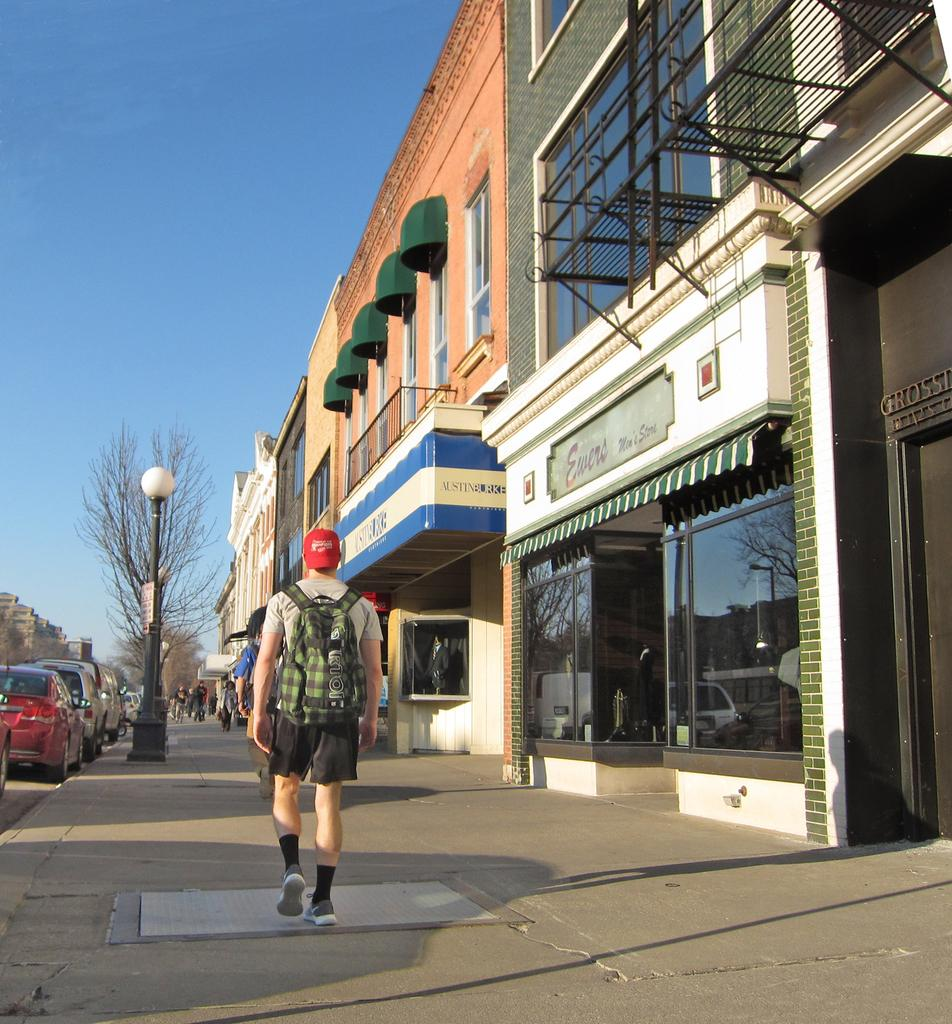What type of structures can be seen in the image? There are buildings in the image. What vehicles are present in the image? There are cars in the image. What type of vegetation is visible in the image? There are trees in the image. What object is present that is typically used for supporting or holding something? There is a pole in the image. What objects are present that might be used for displaying information or advertisements? There are boards in the image. Are there any people visible in the image? Yes, there are persons in the image. What part of the natural environment can be seen in the background of the image? The sky is visible in the background of the image. What type of oil can be seen dripping from the cars in the image? There is no oil dripping from the cars in the image. What book is the person reading in the image? There is no person reading a book in the image. 